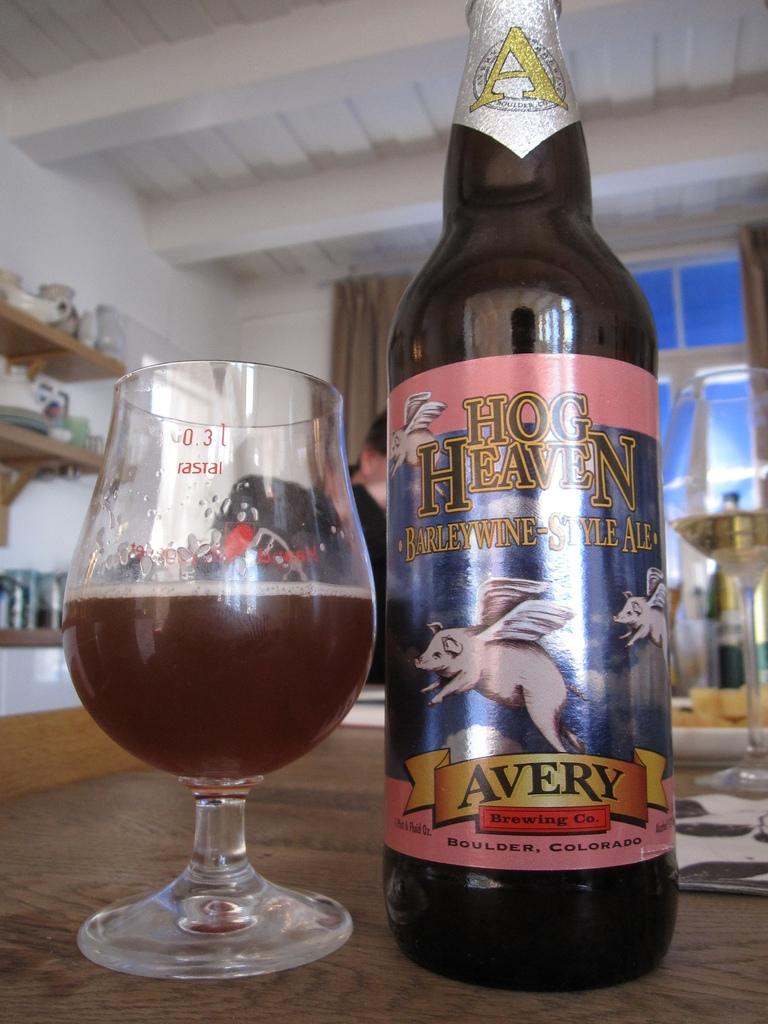<image>
Create a compact narrative representing the image presented. A bottle of Hog Heaven brand ale is next to a glass that is half full. 